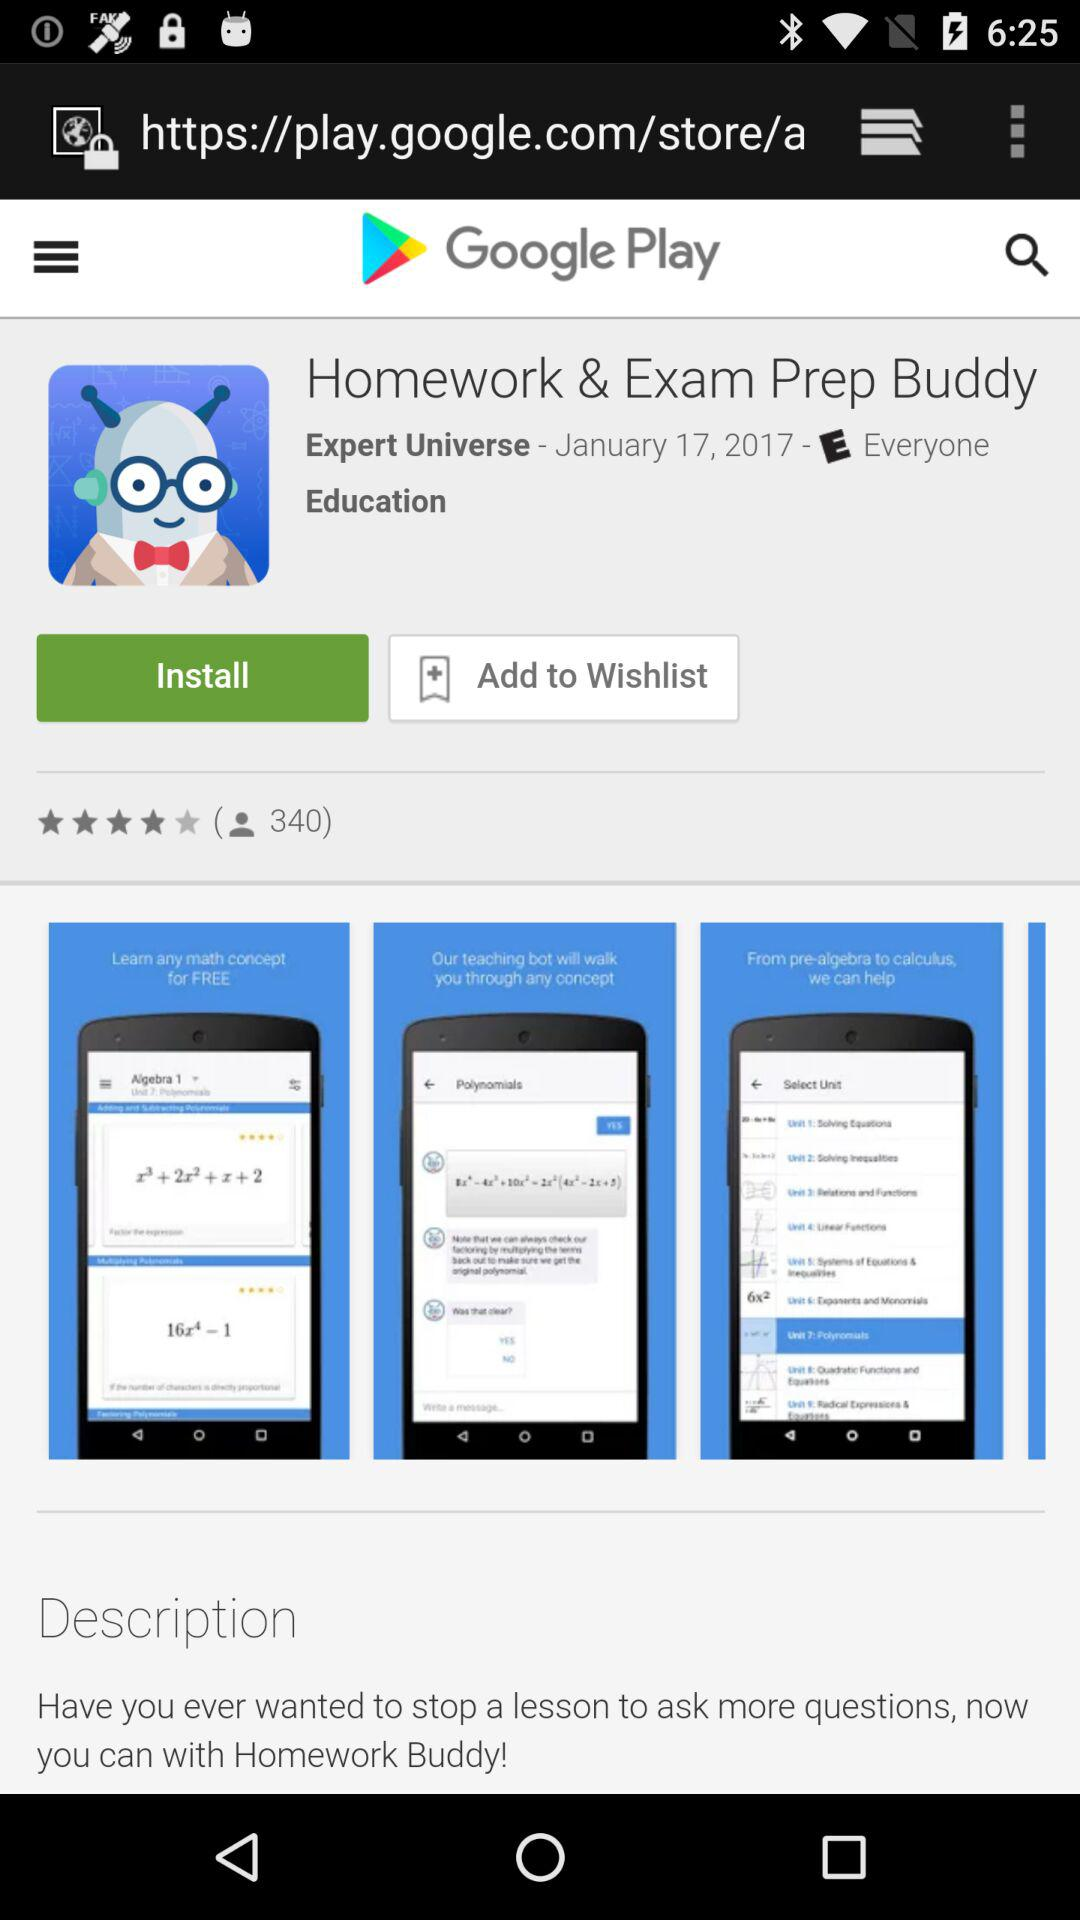What is the star rating of the application "Homework & Exam Prep Buddy"? The rating is 4 stars. 